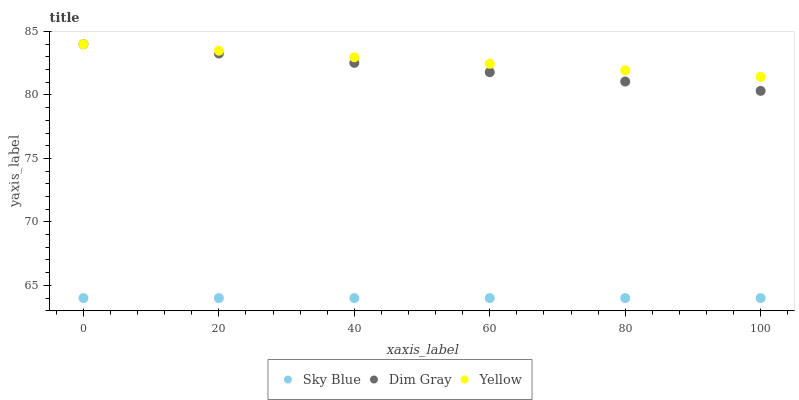Does Sky Blue have the minimum area under the curve?
Answer yes or no. Yes. Does Yellow have the maximum area under the curve?
Answer yes or no. Yes. Does Dim Gray have the minimum area under the curve?
Answer yes or no. No. Does Dim Gray have the maximum area under the curve?
Answer yes or no. No. Is Sky Blue the smoothest?
Answer yes or no. Yes. Is Yellow the roughest?
Answer yes or no. Yes. Is Dim Gray the smoothest?
Answer yes or no. No. Is Dim Gray the roughest?
Answer yes or no. No. Does Sky Blue have the lowest value?
Answer yes or no. Yes. Does Dim Gray have the lowest value?
Answer yes or no. No. Does Yellow have the highest value?
Answer yes or no. Yes. Is Sky Blue less than Dim Gray?
Answer yes or no. Yes. Is Yellow greater than Sky Blue?
Answer yes or no. Yes. Does Dim Gray intersect Yellow?
Answer yes or no. Yes. Is Dim Gray less than Yellow?
Answer yes or no. No. Is Dim Gray greater than Yellow?
Answer yes or no. No. Does Sky Blue intersect Dim Gray?
Answer yes or no. No. 